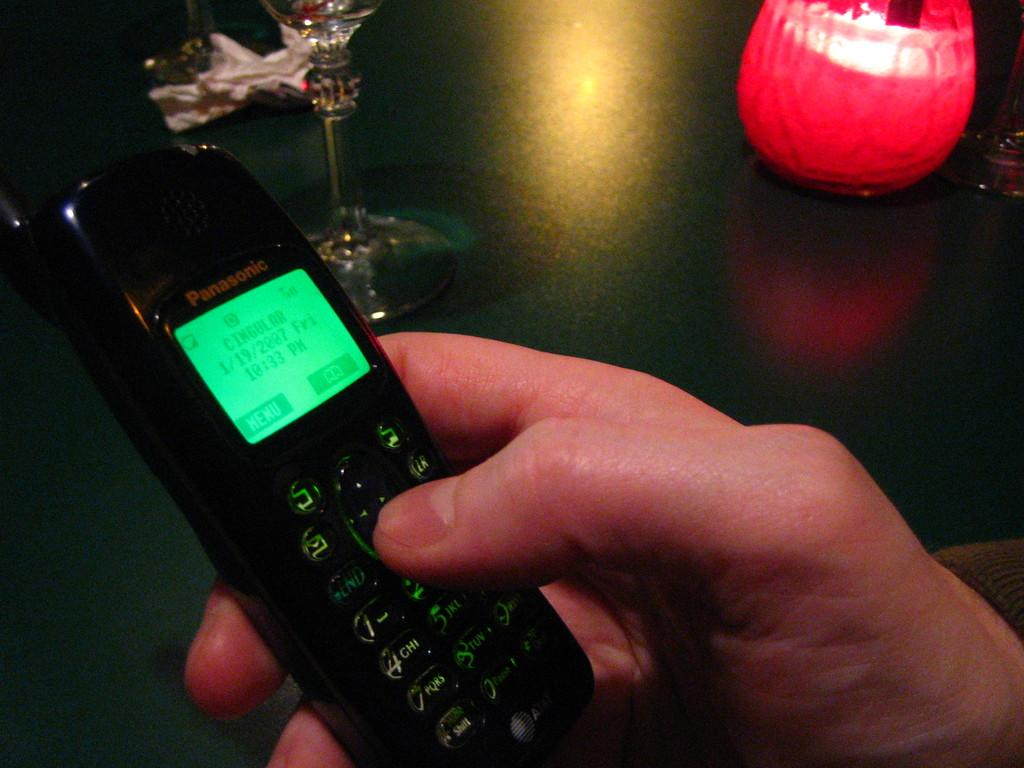Who is present in the image? There is a person in the image. What is the person holding in the image? The person is holding a phone. What other objects can be seen in the image? There is a glass and a lamp in the image. What year does the person regret in the image? There is no indication of regret or a specific year in the image. 